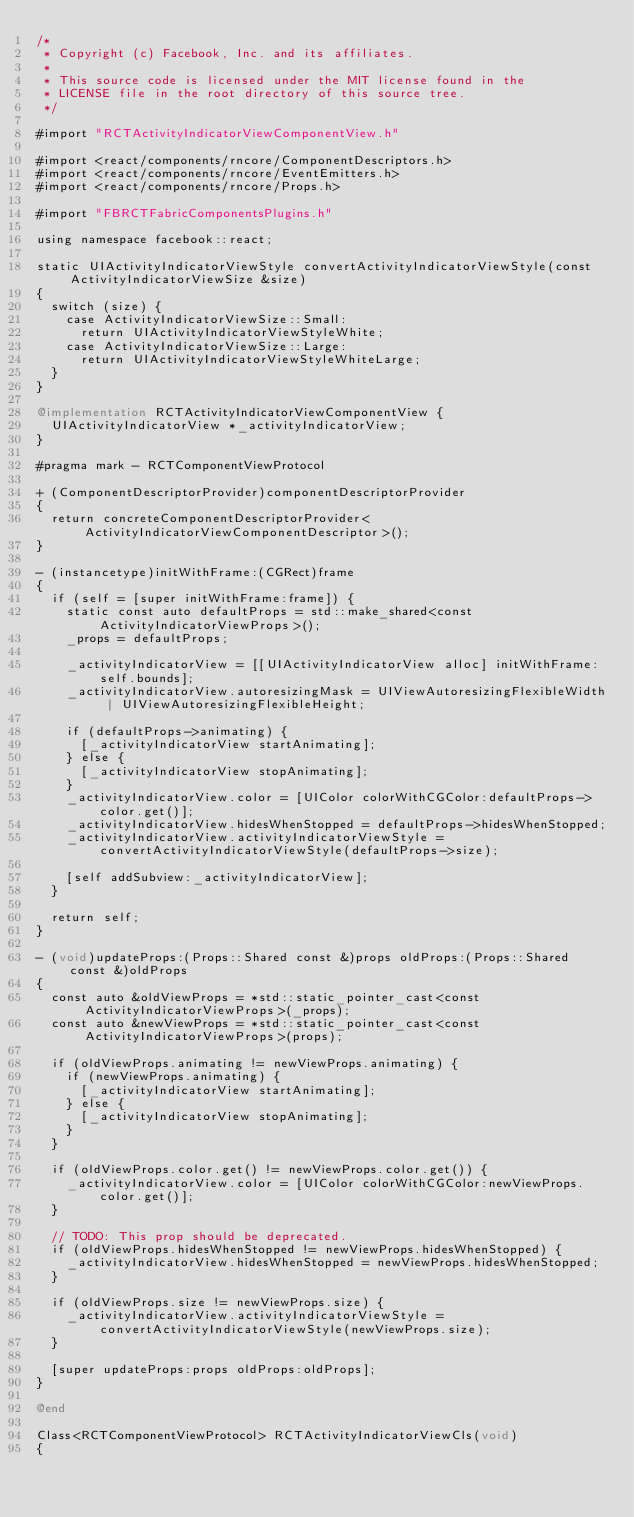<code> <loc_0><loc_0><loc_500><loc_500><_ObjectiveC_>/*
 * Copyright (c) Facebook, Inc. and its affiliates.
 *
 * This source code is licensed under the MIT license found in the
 * LICENSE file in the root directory of this source tree.
 */

#import "RCTActivityIndicatorViewComponentView.h"

#import <react/components/rncore/ComponentDescriptors.h>
#import <react/components/rncore/EventEmitters.h>
#import <react/components/rncore/Props.h>

#import "FBRCTFabricComponentsPlugins.h"

using namespace facebook::react;

static UIActivityIndicatorViewStyle convertActivityIndicatorViewStyle(const ActivityIndicatorViewSize &size)
{
  switch (size) {
    case ActivityIndicatorViewSize::Small:
      return UIActivityIndicatorViewStyleWhite;
    case ActivityIndicatorViewSize::Large:
      return UIActivityIndicatorViewStyleWhiteLarge;
  }
}

@implementation RCTActivityIndicatorViewComponentView {
  UIActivityIndicatorView *_activityIndicatorView;
}

#pragma mark - RCTComponentViewProtocol

+ (ComponentDescriptorProvider)componentDescriptorProvider
{
  return concreteComponentDescriptorProvider<ActivityIndicatorViewComponentDescriptor>();
}

- (instancetype)initWithFrame:(CGRect)frame
{
  if (self = [super initWithFrame:frame]) {
    static const auto defaultProps = std::make_shared<const ActivityIndicatorViewProps>();
    _props = defaultProps;

    _activityIndicatorView = [[UIActivityIndicatorView alloc] initWithFrame:self.bounds];
    _activityIndicatorView.autoresizingMask = UIViewAutoresizingFlexibleWidth | UIViewAutoresizingFlexibleHeight;

    if (defaultProps->animating) {
      [_activityIndicatorView startAnimating];
    } else {
      [_activityIndicatorView stopAnimating];
    }
    _activityIndicatorView.color = [UIColor colorWithCGColor:defaultProps->color.get()];
    _activityIndicatorView.hidesWhenStopped = defaultProps->hidesWhenStopped;
    _activityIndicatorView.activityIndicatorViewStyle = convertActivityIndicatorViewStyle(defaultProps->size);

    [self addSubview:_activityIndicatorView];
  }

  return self;
}

- (void)updateProps:(Props::Shared const &)props oldProps:(Props::Shared const &)oldProps
{
  const auto &oldViewProps = *std::static_pointer_cast<const ActivityIndicatorViewProps>(_props);
  const auto &newViewProps = *std::static_pointer_cast<const ActivityIndicatorViewProps>(props);

  if (oldViewProps.animating != newViewProps.animating) {
    if (newViewProps.animating) {
      [_activityIndicatorView startAnimating];
    } else {
      [_activityIndicatorView stopAnimating];
    }
  }

  if (oldViewProps.color.get() != newViewProps.color.get()) {
    _activityIndicatorView.color = [UIColor colorWithCGColor:newViewProps.color.get()];
  }

  // TODO: This prop should be deprecated.
  if (oldViewProps.hidesWhenStopped != newViewProps.hidesWhenStopped) {
    _activityIndicatorView.hidesWhenStopped = newViewProps.hidesWhenStopped;
  }

  if (oldViewProps.size != newViewProps.size) {
    _activityIndicatorView.activityIndicatorViewStyle = convertActivityIndicatorViewStyle(newViewProps.size);
  }

  [super updateProps:props oldProps:oldProps];
}

@end

Class<RCTComponentViewProtocol> RCTActivityIndicatorViewCls(void)
{</code> 